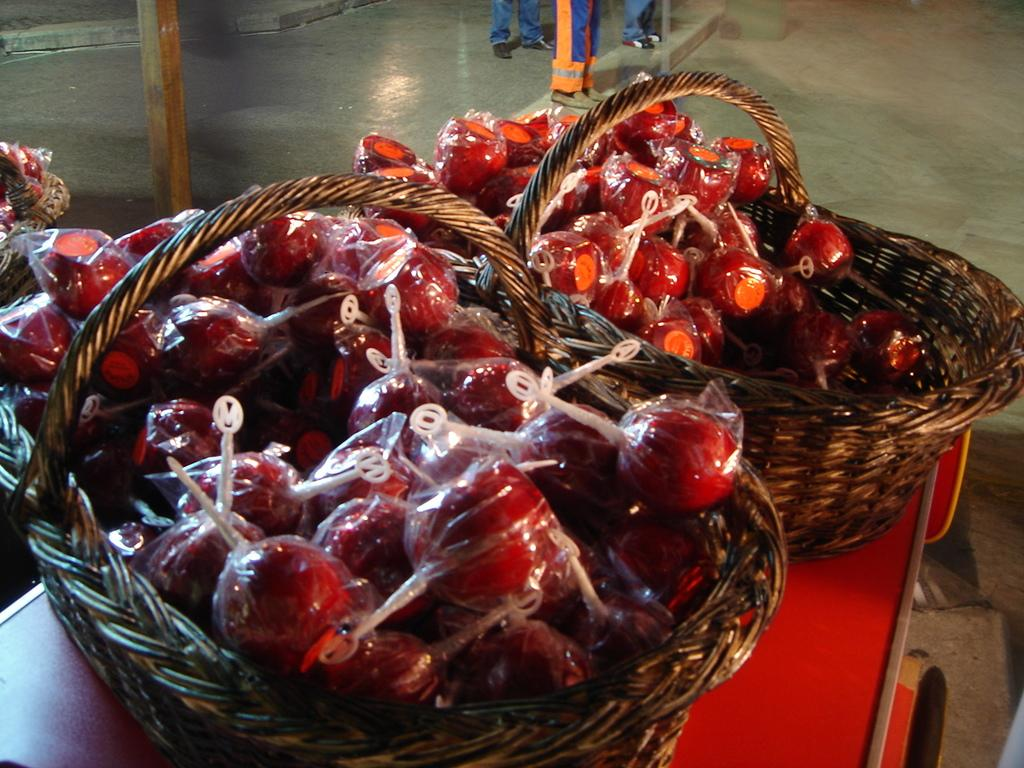What type of fruit is in the basket in the image? There are strawberries in a basket in the image. Where is the basket located? The basket is placed on a table. Can you describe anything visible in the background of the image? Persons' legs are visible in the background of the image. What type of clock is hanging on the wall in the image? There is no clock visible in the image; it only shows a basket of strawberries on a table and persons' legs in the background. 